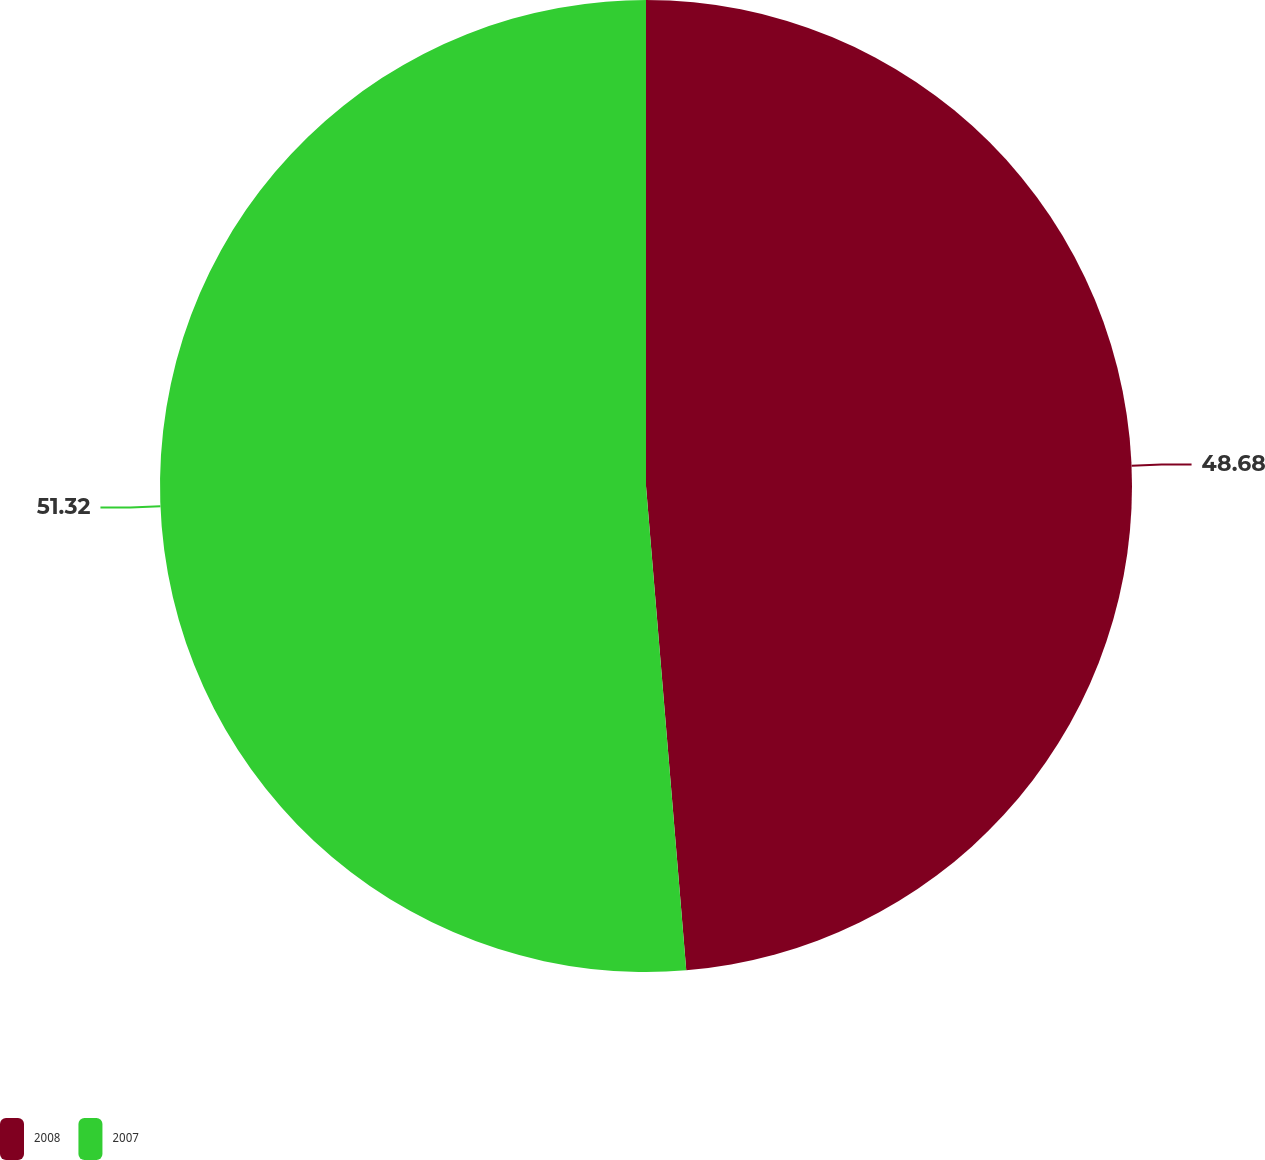<chart> <loc_0><loc_0><loc_500><loc_500><pie_chart><fcel>2008<fcel>2007<nl><fcel>48.68%<fcel>51.32%<nl></chart> 